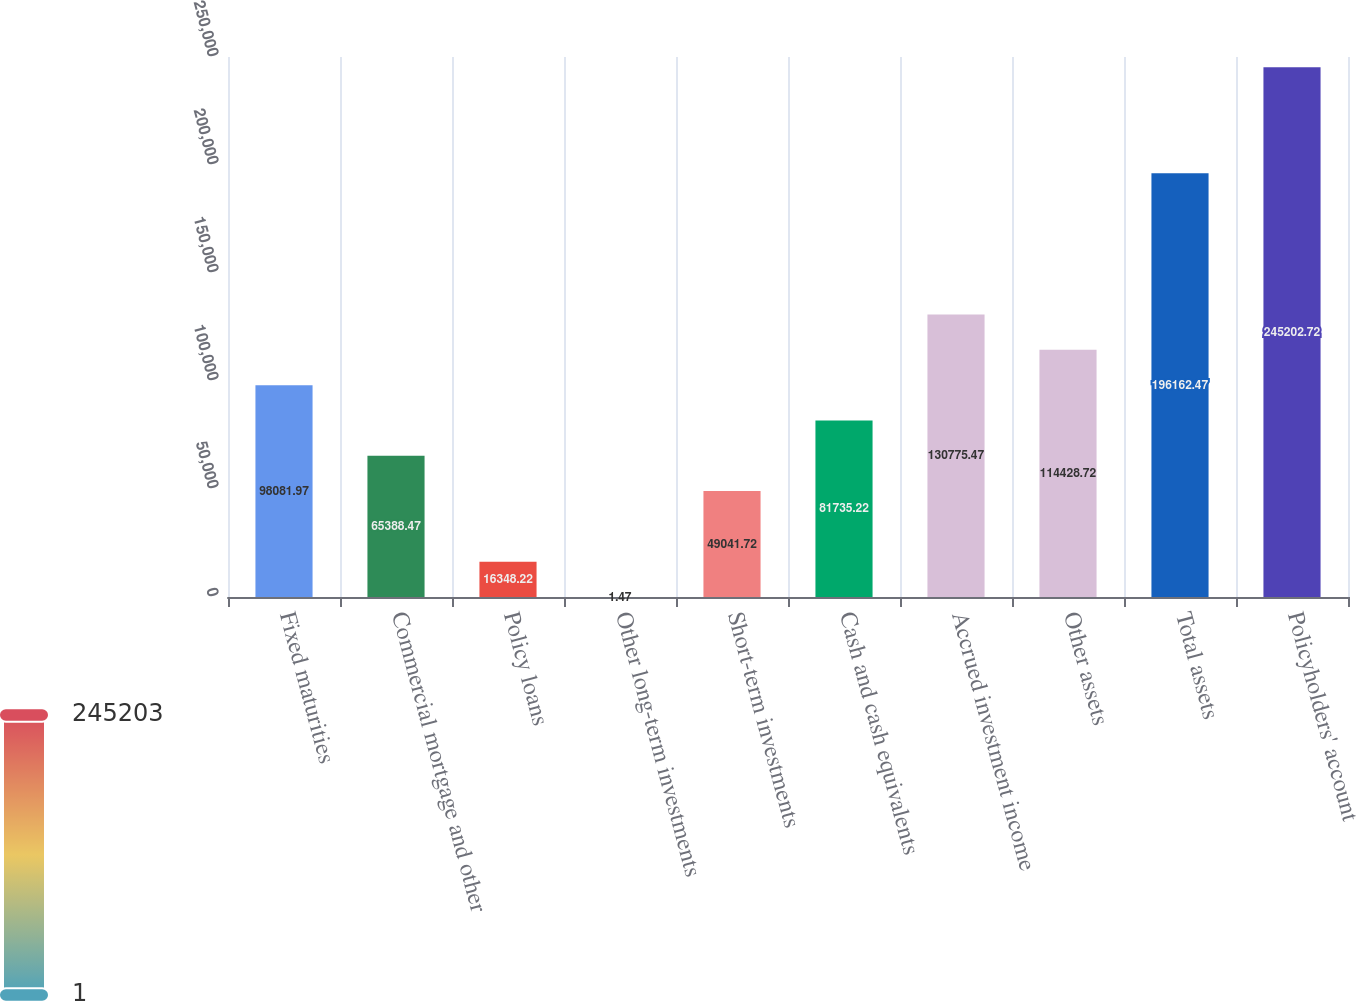Convert chart. <chart><loc_0><loc_0><loc_500><loc_500><bar_chart><fcel>Fixed maturities<fcel>Commercial mortgage and other<fcel>Policy loans<fcel>Other long-term investments<fcel>Short-term investments<fcel>Cash and cash equivalents<fcel>Accrued investment income<fcel>Other assets<fcel>Total assets<fcel>Policyholders' account<nl><fcel>98082<fcel>65388.5<fcel>16348.2<fcel>1.47<fcel>49041.7<fcel>81735.2<fcel>130775<fcel>114429<fcel>196162<fcel>245203<nl></chart> 